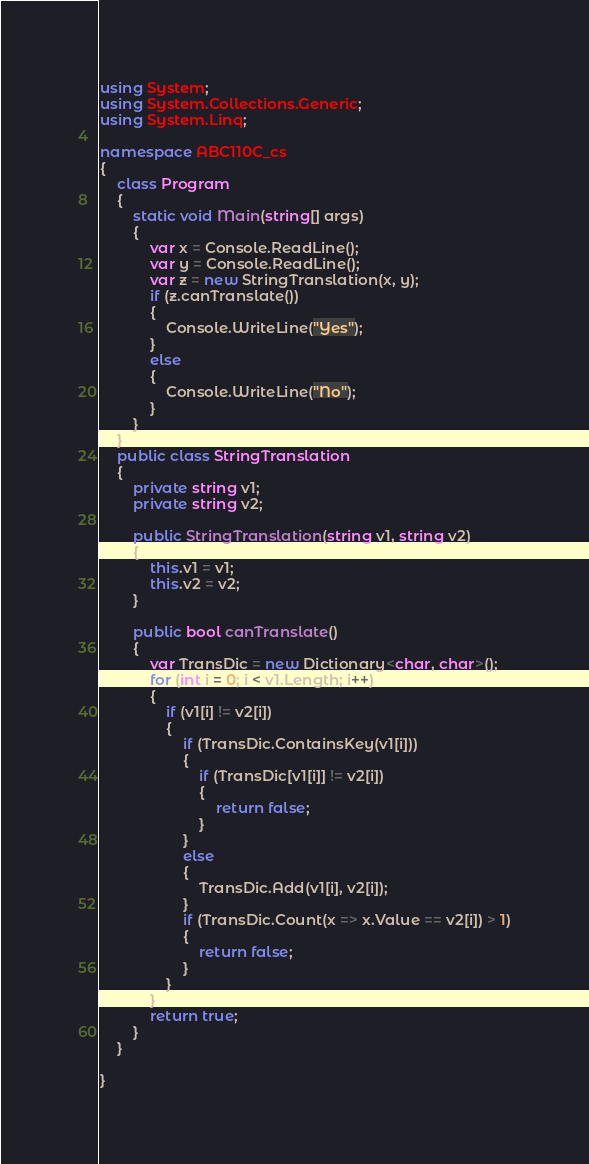Convert code to text. <code><loc_0><loc_0><loc_500><loc_500><_C#_>using System;
using System.Collections.Generic;
using System.Linq;

namespace ABC110C_cs
{
    class Program
    {
        static void Main(string[] args)
        {
            var x = Console.ReadLine();
            var y = Console.ReadLine();
            var z = new StringTranslation(x, y);
            if (z.canTranslate())
            {
                Console.WriteLine("Yes");
            }
            else
            {
                Console.WriteLine("No");
            }
        }
    }
    public class StringTranslation
    {
        private string v1;
        private string v2;

        public StringTranslation(string v1, string v2)
        {
            this.v1 = v1;
            this.v2 = v2;
        }

        public bool canTranslate()
        {
            var TransDic = new Dictionary<char, char>();
            for (int i = 0; i < v1.Length; i++)
            {
                if (v1[i] != v2[i])
                {
                    if (TransDic.ContainsKey(v1[i]))
                    {
                        if (TransDic[v1[i]] != v2[i])
                        {
                            return false;
                        }
                    }
                    else
                    {
                        TransDic.Add(v1[i], v2[i]);
                    }
                    if (TransDic.Count(x => x.Value == v2[i]) > 1)
                    {
                        return false;
                    }
                }
            }
            return true;
        }
    }

}
</code> 